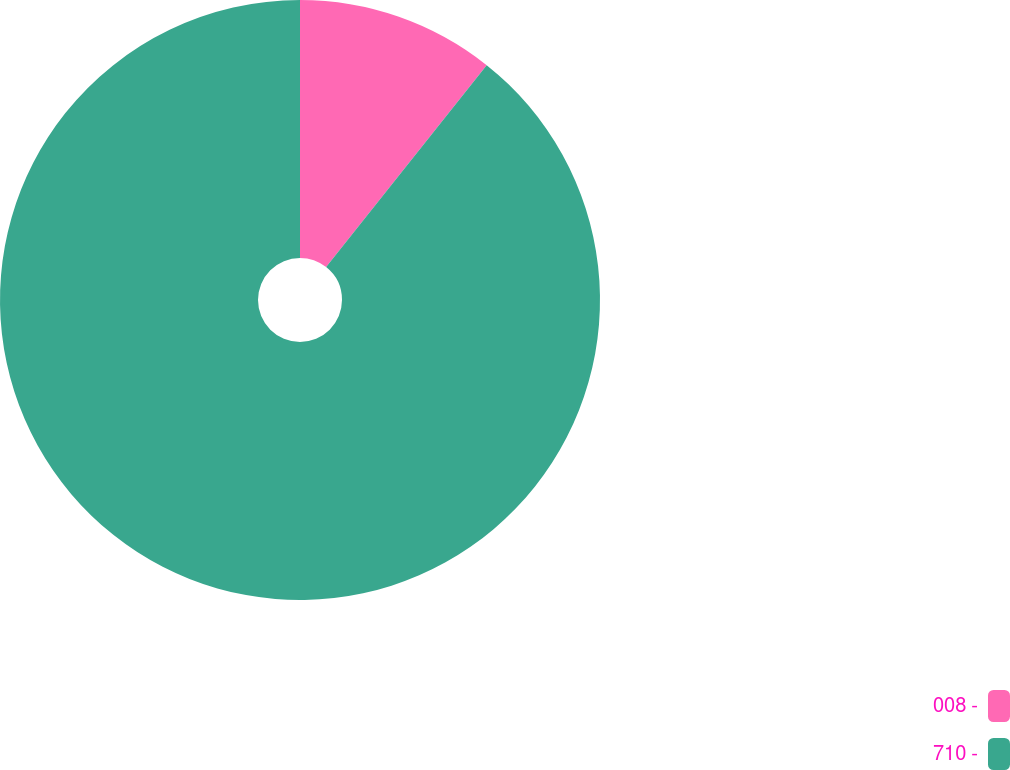Convert chart to OTSL. <chart><loc_0><loc_0><loc_500><loc_500><pie_chart><fcel>008 -<fcel>710 -<nl><fcel>10.69%<fcel>89.31%<nl></chart> 